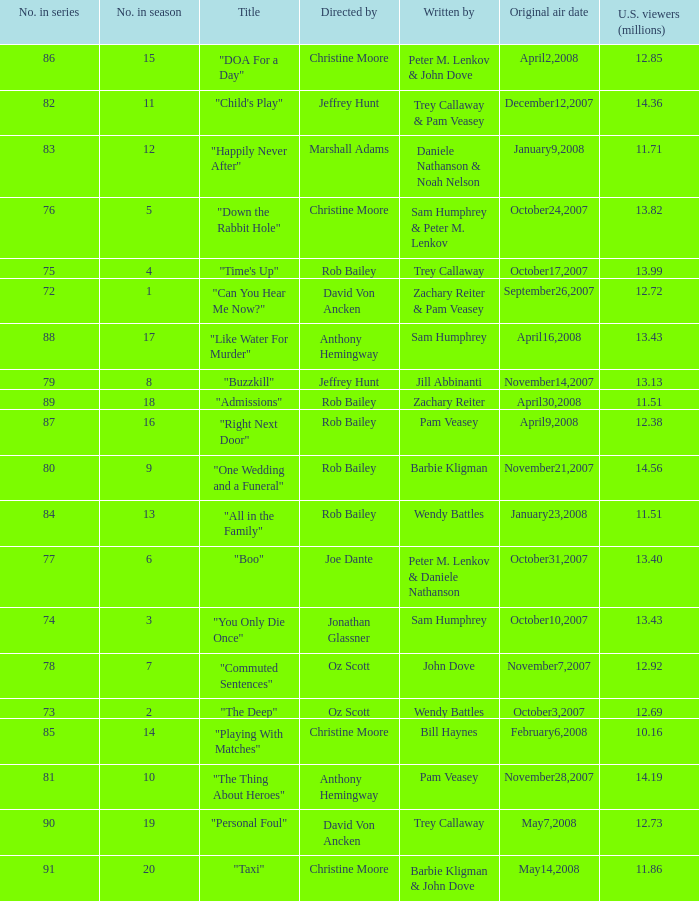How many millions of U.S. viewers watched the episode directed by Rob Bailey and written by Pam Veasey? 12.38. 